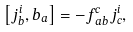<formula> <loc_0><loc_0><loc_500><loc_500>\left [ j _ { b } ^ { i } , b _ { a } \right ] = - f _ { \, a b } ^ { c } j _ { c } ^ { i } ,</formula> 